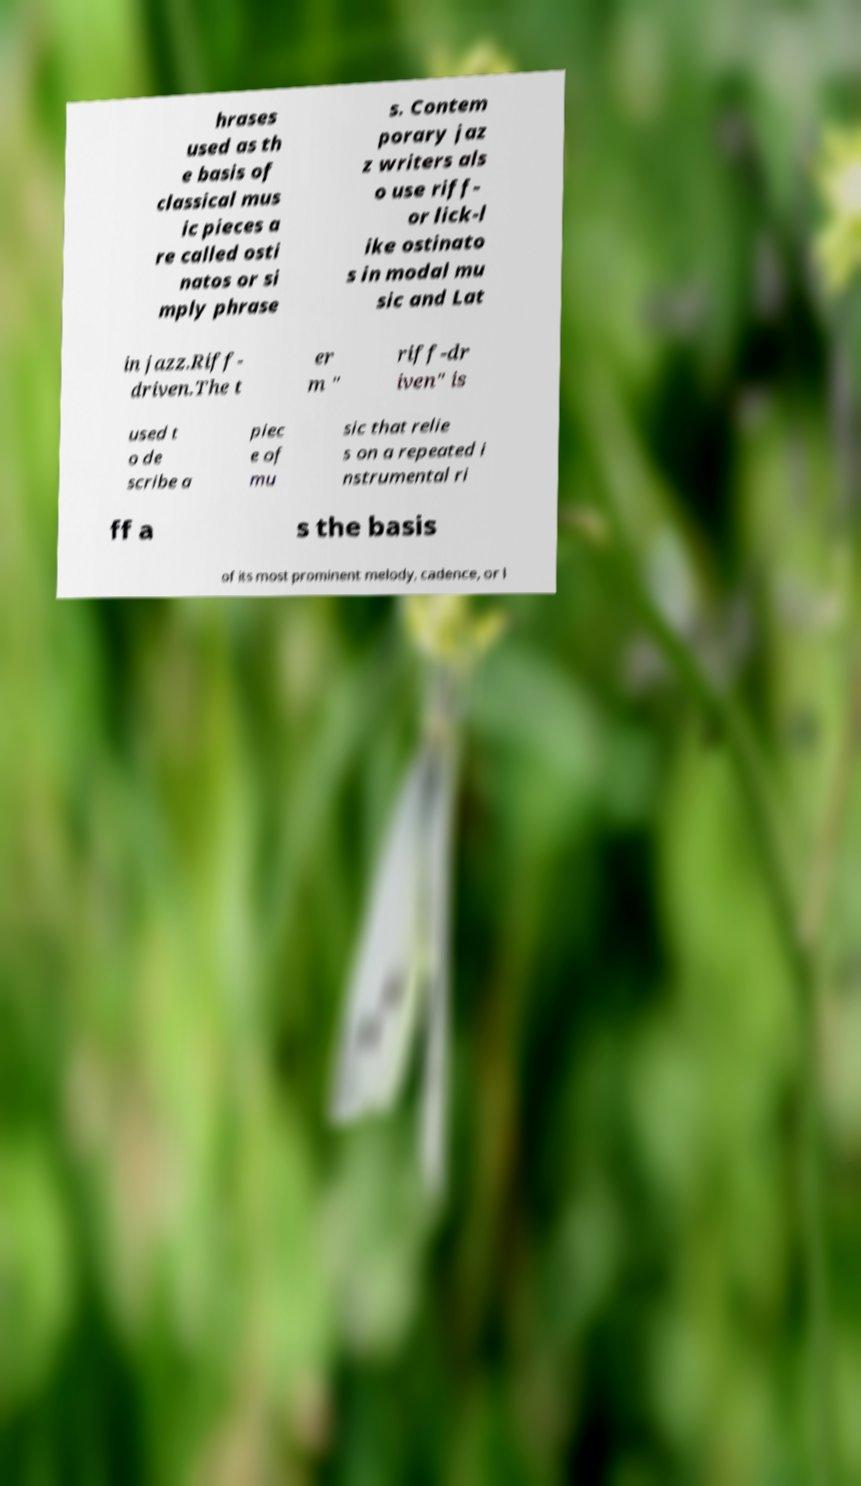Can you accurately transcribe the text from the provided image for me? hrases used as th e basis of classical mus ic pieces a re called osti natos or si mply phrase s. Contem porary jaz z writers als o use riff- or lick-l ike ostinato s in modal mu sic and Lat in jazz.Riff- driven.The t er m " riff-dr iven" is used t o de scribe a piec e of mu sic that relie s on a repeated i nstrumental ri ff a s the basis of its most prominent melody, cadence, or l 